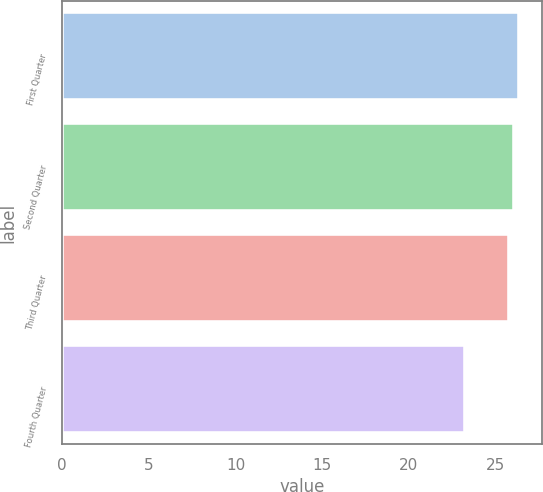Convert chart to OTSL. <chart><loc_0><loc_0><loc_500><loc_500><bar_chart><fcel>First Quarter<fcel>Second Quarter<fcel>Third Quarter<fcel>Fourth Quarter<nl><fcel>26.34<fcel>26.07<fcel>25.8<fcel>23.22<nl></chart> 